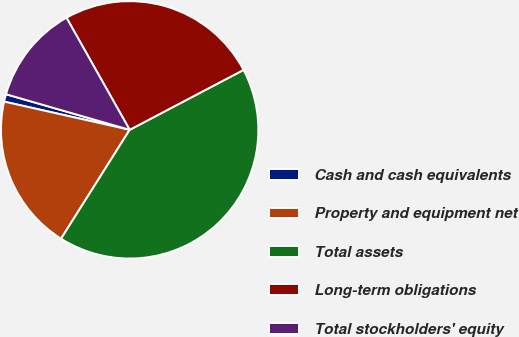Convert chart. <chart><loc_0><loc_0><loc_500><loc_500><pie_chart><fcel>Cash and cash equivalents<fcel>Property and equipment net<fcel>Total assets<fcel>Long-term obligations<fcel>Total stockholders' equity<nl><fcel>0.94%<fcel>19.57%<fcel>41.66%<fcel>25.46%<fcel>12.37%<nl></chart> 